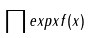<formula> <loc_0><loc_0><loc_500><loc_500>\prod e x p x f ( x )</formula> 